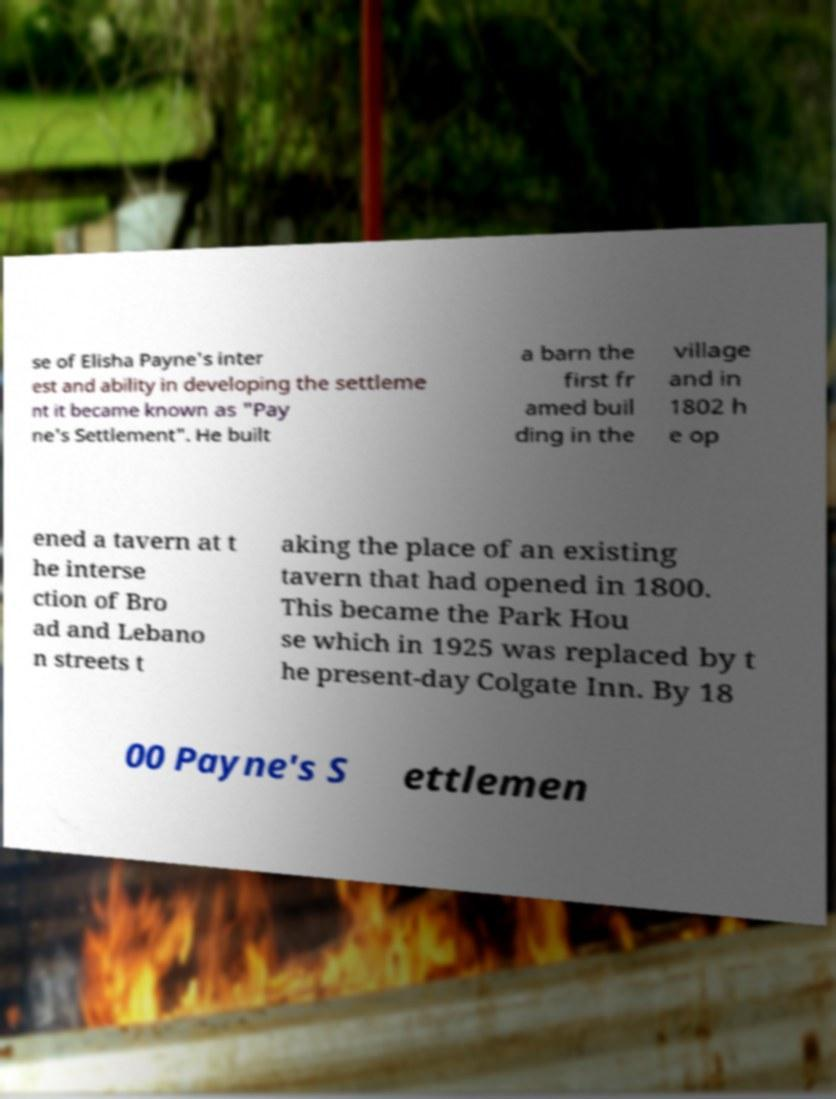Could you extract and type out the text from this image? se of Elisha Payne's inter est and ability in developing the settleme nt it became known as "Pay ne's Settlement". He built a barn the first fr amed buil ding in the village and in 1802 h e op ened a tavern at t he interse ction of Bro ad and Lebano n streets t aking the place of an existing tavern that had opened in 1800. This became the Park Hou se which in 1925 was replaced by t he present-day Colgate Inn. By 18 00 Payne's S ettlemen 